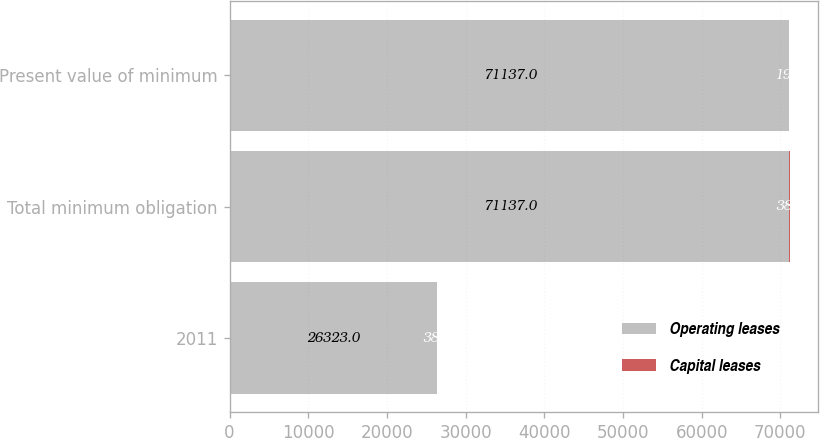Convert chart. <chart><loc_0><loc_0><loc_500><loc_500><stacked_bar_chart><ecel><fcel>2011<fcel>Total minimum obligation<fcel>Present value of minimum<nl><fcel>Operating leases<fcel>26323<fcel>71137<fcel>71137<nl><fcel>Capital leases<fcel>38<fcel>38<fcel>19<nl></chart> 